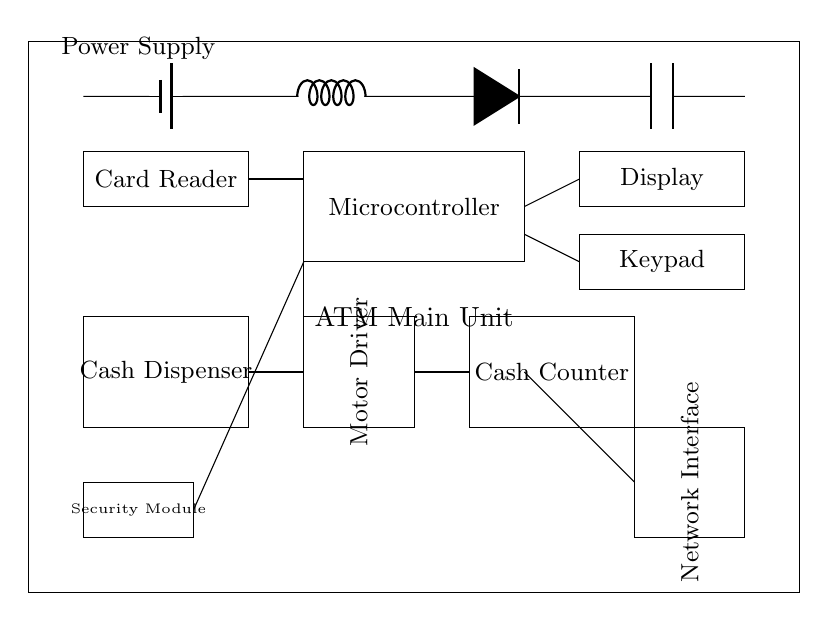What is the main power source of the ATM? The main power source is a battery represented by the battery symbol near the top left corner, providing voltage to the other components of the ATM circuit.
Answer: Battery How many user interface components are in the diagram? There are two user interface components: the display and the keypad, both located at the top right section of the main unit.
Answer: Two What is the function of the microcontroller in this circuit? The microcontroller is responsible for the overall control and processing of the ATM's operations, coordinating actions between the card reader, user interface, and cash dispenser.
Answer: Control Which component directly connects to the cash counter? The cash dispenser directly connects to the cash counter through a line, indicating that the cash amount is counted after dispensing.
Answer: Cash Dispenser What role does the security module play in the ATM circuit? The security module is crucial for ensuring the secure handling of user data and transactions, as it connects to the microcontroller, enhancing overall security.
Answer: Security How is the cash dispenser powered in this circuit? The cash dispenser is powered through its connection to the microcontroller, which controls the cash dispensing process and ensures it receives necessary power.
Answer: Microcontroller What is the orientation of the motor driver component? The motor driver is vertically oriented according to the diagram, indicated by its rotated label, showing its specific positioning within the main ATM unit.
Answer: Vertical 